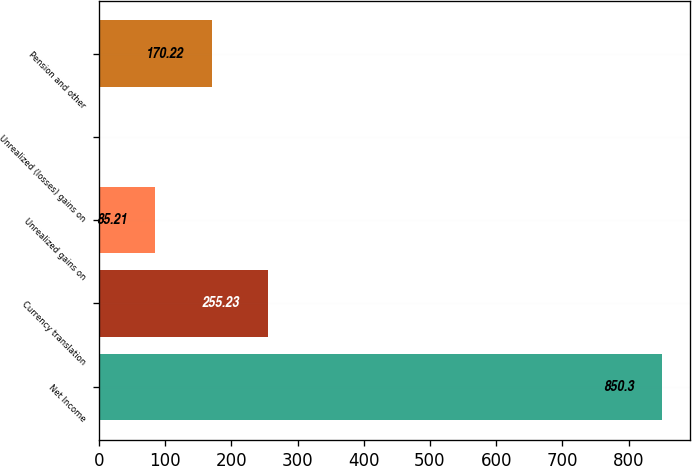Convert chart to OTSL. <chart><loc_0><loc_0><loc_500><loc_500><bar_chart><fcel>Net Income<fcel>Currency translation<fcel>Unrealized gains on<fcel>Unrealized (losses) gains on<fcel>Pension and other<nl><fcel>850.3<fcel>255.23<fcel>85.21<fcel>0.2<fcel>170.22<nl></chart> 